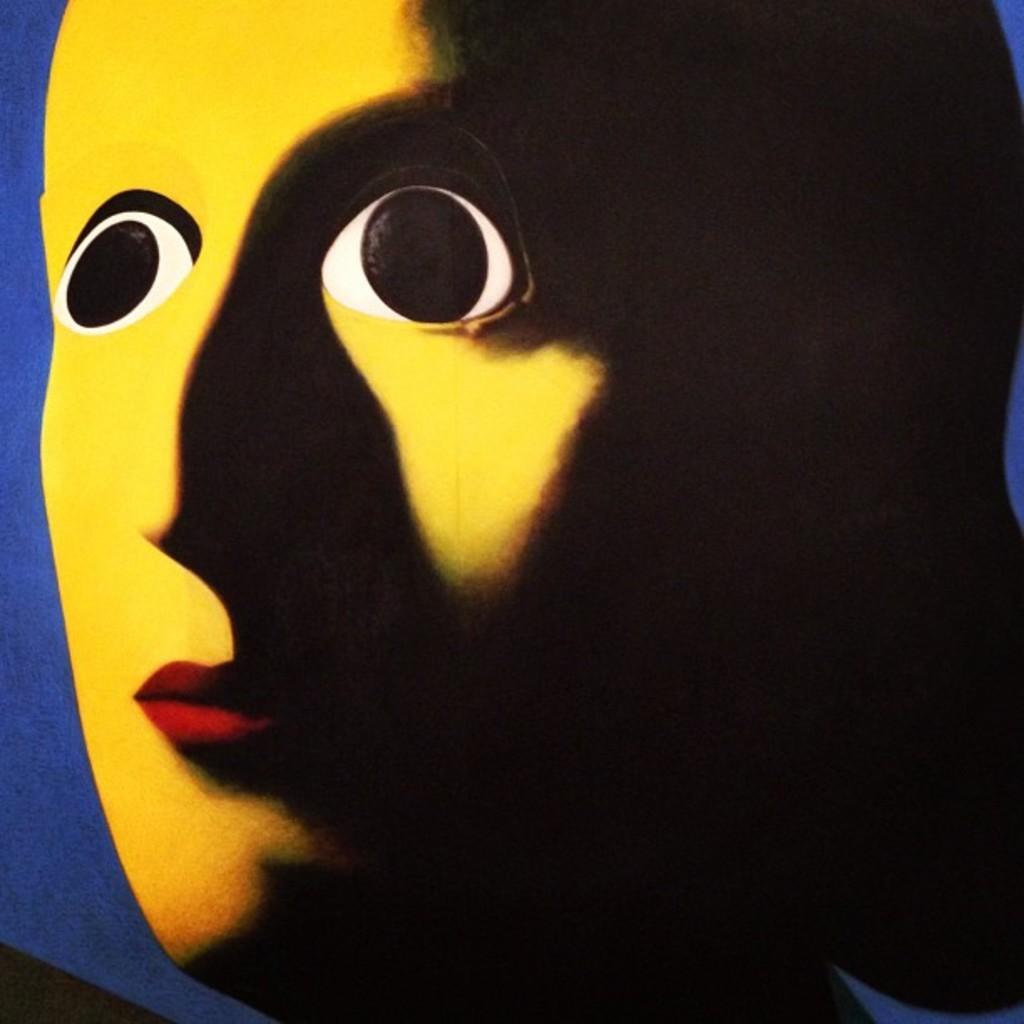Please provide a concise description of this image. There is a yellow mask and on the right side of the mask there is a black shadow. 